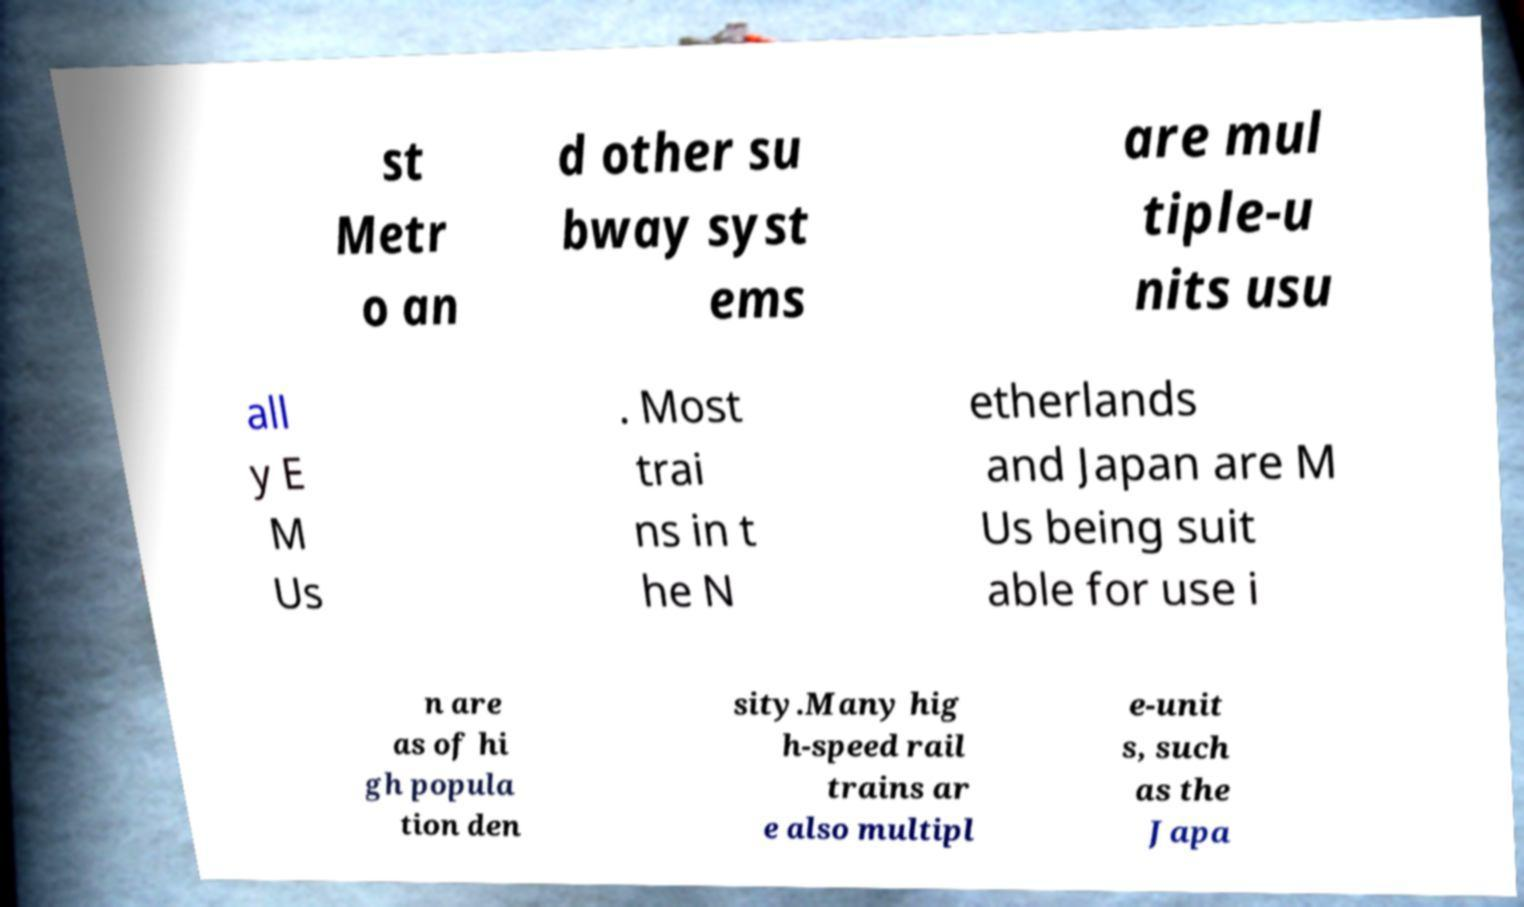What messages or text are displayed in this image? I need them in a readable, typed format. st Metr o an d other su bway syst ems are mul tiple-u nits usu all y E M Us . Most trai ns in t he N etherlands and Japan are M Us being suit able for use i n are as of hi gh popula tion den sity.Many hig h-speed rail trains ar e also multipl e-unit s, such as the Japa 